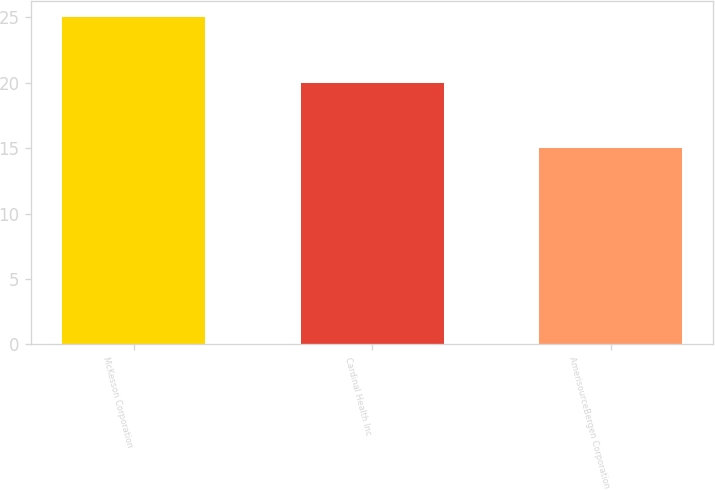Convert chart to OTSL. <chart><loc_0><loc_0><loc_500><loc_500><bar_chart><fcel>McKesson Corporation<fcel>Cardinal Health Inc<fcel>AmerisourceBergen Corporation<nl><fcel>25<fcel>20<fcel>15<nl></chart> 